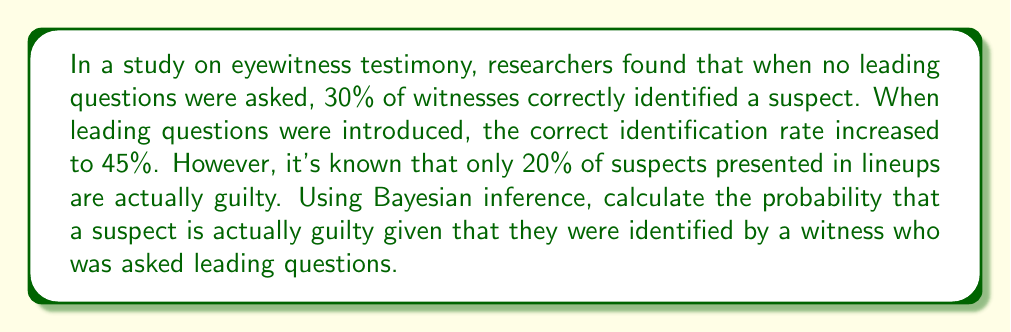Solve this math problem. Let's approach this step-by-step using Bayesian inference:

1) Define our events:
   G: The suspect is guilty
   I: The witness identifies the suspect

2) Given information:
   P(G) = 0.20 (prior probability of guilt)
   P(I|G) = 0.45 (probability of identification given guilt, with leading questions)
   P(I|not G) = 0.45 (probability of identification given innocence, with leading questions)

3) We want to find P(G|I) using Bayes' theorem:

   $$P(G|I) = \frac{P(I|G) \cdot P(G)}{P(I)}$$

4) We need to calculate P(I):
   
   $$P(I) = P(I|G) \cdot P(G) + P(I|not G) \cdot P(not G)$$

5) Calculate P(not G):
   
   $$P(not G) = 1 - P(G) = 1 - 0.20 = 0.80$$

6) Now we can calculate P(I):
   
   $$P(I) = 0.45 \cdot 0.20 + 0.45 \cdot 0.80 = 0.09 + 0.36 = 0.45$$

7) Finally, we can calculate P(G|I):

   $$P(G|I) = \frac{0.45 \cdot 0.20}{0.45} = \frac{0.09}{0.45} = 0.20$$

Therefore, the probability that a suspect is actually guilty given that they were identified by a witness who was asked leading questions is 0.20 or 20%.
Answer: 0.20 